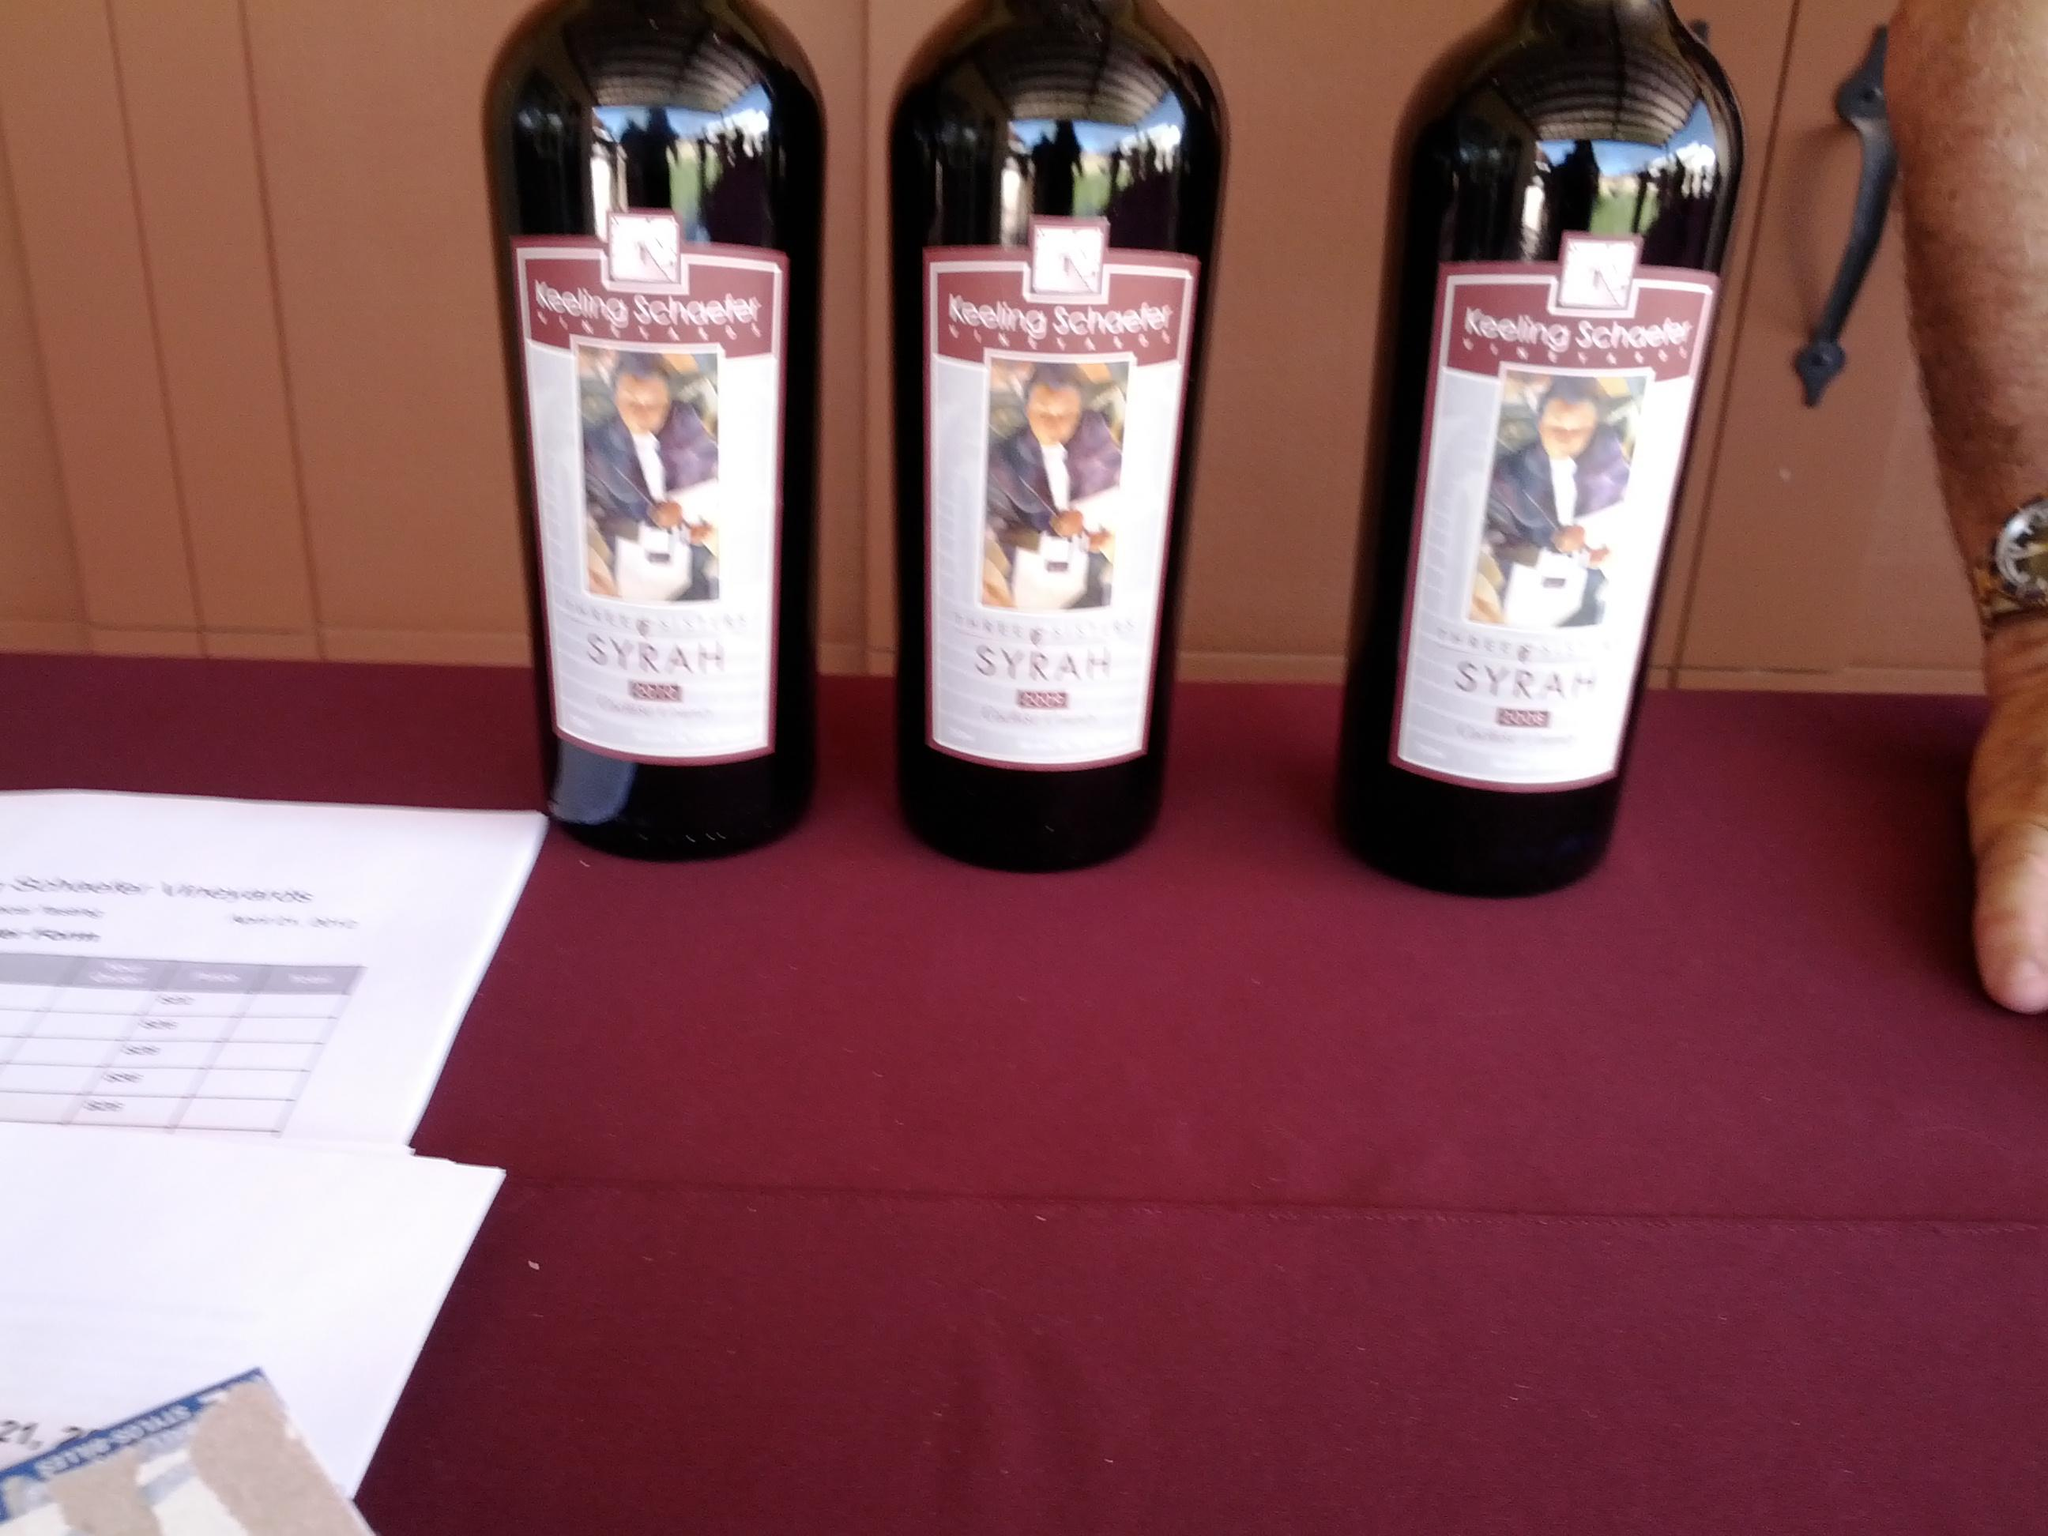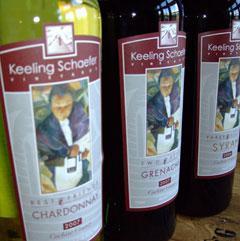The first image is the image on the left, the second image is the image on the right. Examine the images to the left and right. Is the description "Left image shows at least four wine bottles of various colors, arranged in a horizontal row." accurate? Answer yes or no. No. 